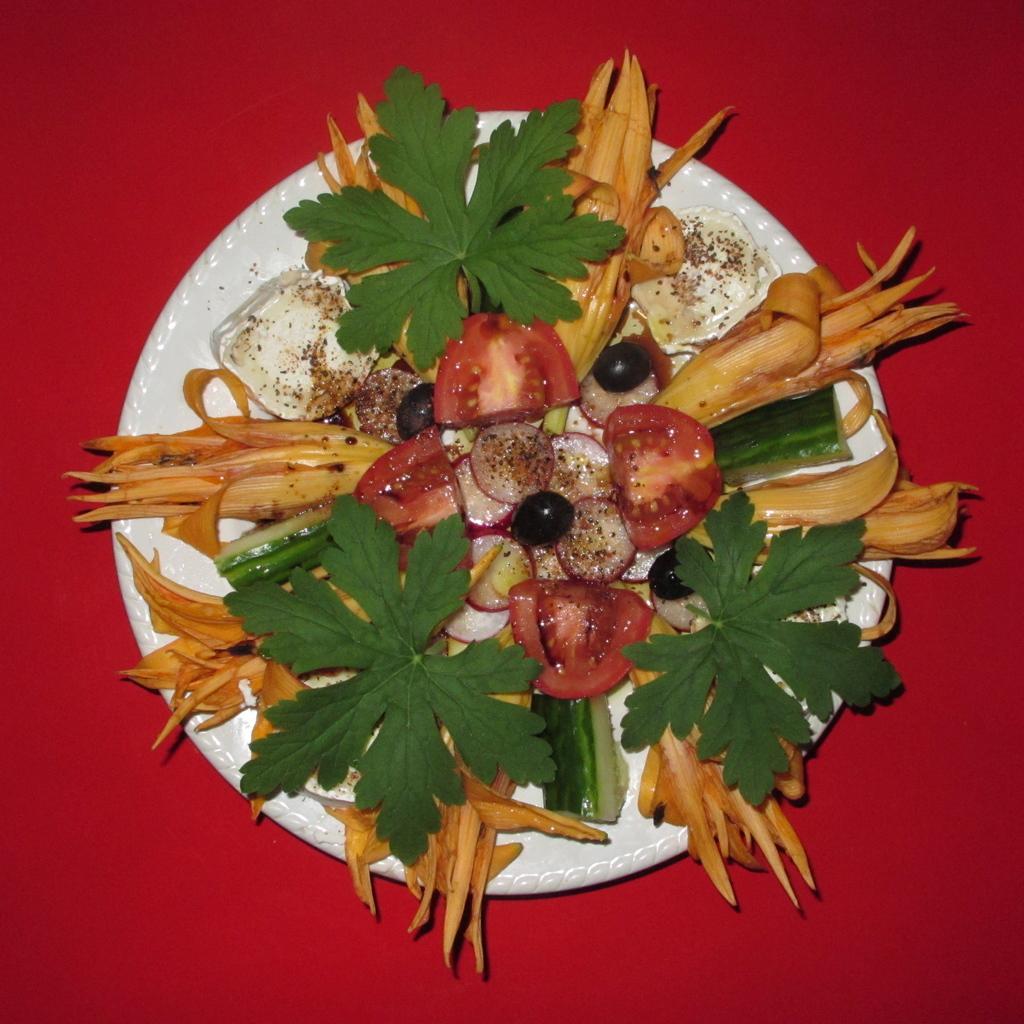Describe this image in one or two sentences. In this picture we can see a plate and food. 